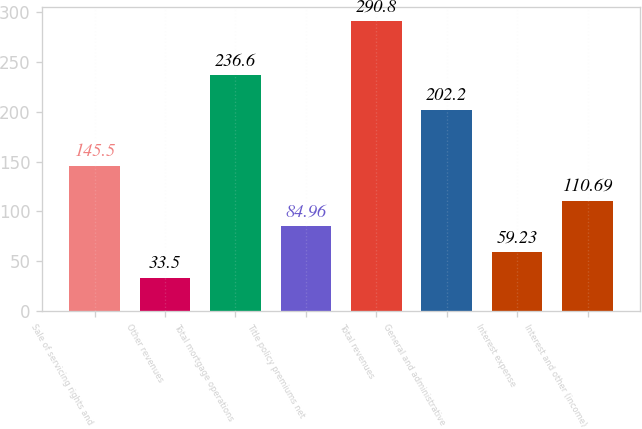Convert chart to OTSL. <chart><loc_0><loc_0><loc_500><loc_500><bar_chart><fcel>Sale of servicing rights and<fcel>Other revenues<fcel>Total mortgage operations<fcel>Title policy premiums net<fcel>Total revenues<fcel>General and administrative<fcel>Interest expense<fcel>Interest and other (income)<nl><fcel>145.5<fcel>33.5<fcel>236.6<fcel>84.96<fcel>290.8<fcel>202.2<fcel>59.23<fcel>110.69<nl></chart> 